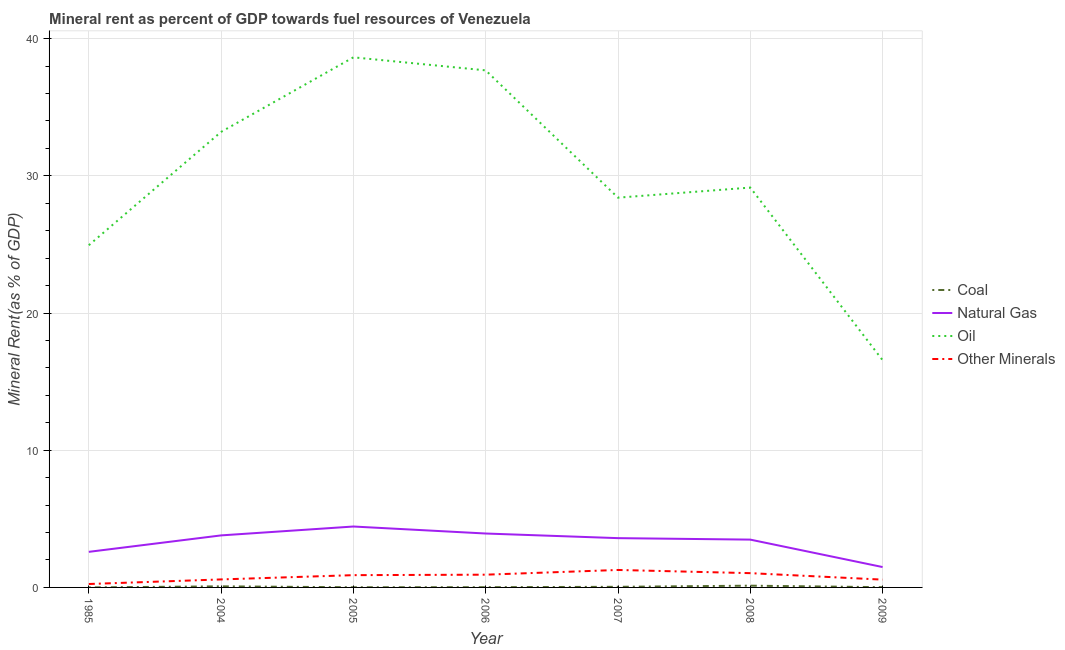Is the number of lines equal to the number of legend labels?
Offer a terse response. Yes. What is the coal rent in 2008?
Provide a short and direct response. 0.13. Across all years, what is the maximum  rent of other minerals?
Your answer should be compact. 1.27. Across all years, what is the minimum oil rent?
Make the answer very short. 16.57. In which year was the natural gas rent maximum?
Your answer should be compact. 2005. In which year was the  rent of other minerals minimum?
Give a very brief answer. 1985. What is the total oil rent in the graph?
Ensure brevity in your answer.  208.6. What is the difference between the oil rent in 2006 and that in 2009?
Provide a succinct answer. 21.13. What is the difference between the coal rent in 2009 and the oil rent in 2005?
Your answer should be very brief. -38.62. What is the average coal rent per year?
Ensure brevity in your answer.  0.04. In the year 2008, what is the difference between the natural gas rent and oil rent?
Ensure brevity in your answer.  -25.66. What is the ratio of the  rent of other minerals in 2006 to that in 2009?
Give a very brief answer. 1.64. Is the difference between the coal rent in 1985 and 2006 greater than the difference between the oil rent in 1985 and 2006?
Keep it short and to the point. Yes. What is the difference between the highest and the second highest oil rent?
Provide a succinct answer. 0.95. What is the difference between the highest and the lowest coal rent?
Your response must be concise. 0.13. In how many years, is the oil rent greater than the average oil rent taken over all years?
Your answer should be compact. 3. Is it the case that in every year, the sum of the natural gas rent and coal rent is greater than the sum of  rent of other minerals and oil rent?
Make the answer very short. No. Does the coal rent monotonically increase over the years?
Your answer should be compact. No. Is the coal rent strictly greater than the  rent of other minerals over the years?
Provide a short and direct response. No. How many lines are there?
Offer a terse response. 4. What is the difference between two consecutive major ticks on the Y-axis?
Your answer should be compact. 10. Are the values on the major ticks of Y-axis written in scientific E-notation?
Ensure brevity in your answer.  No. Does the graph contain grids?
Offer a very short reply. Yes. What is the title of the graph?
Give a very brief answer. Mineral rent as percent of GDP towards fuel resources of Venezuela. What is the label or title of the X-axis?
Offer a terse response. Year. What is the label or title of the Y-axis?
Provide a succinct answer. Mineral Rent(as % of GDP). What is the Mineral Rent(as % of GDP) of Coal in 1985?
Offer a very short reply. 0. What is the Mineral Rent(as % of GDP) in Natural Gas in 1985?
Keep it short and to the point. 2.59. What is the Mineral Rent(as % of GDP) in Oil in 1985?
Your answer should be compact. 24.94. What is the Mineral Rent(as % of GDP) in Other Minerals in 1985?
Your answer should be very brief. 0.25. What is the Mineral Rent(as % of GDP) in Coal in 2004?
Your answer should be compact. 0.08. What is the Mineral Rent(as % of GDP) in Natural Gas in 2004?
Provide a short and direct response. 3.79. What is the Mineral Rent(as % of GDP) in Oil in 2004?
Make the answer very short. 33.21. What is the Mineral Rent(as % of GDP) of Other Minerals in 2004?
Provide a short and direct response. 0.58. What is the Mineral Rent(as % of GDP) of Coal in 2005?
Offer a terse response. 0.01. What is the Mineral Rent(as % of GDP) of Natural Gas in 2005?
Offer a terse response. 4.44. What is the Mineral Rent(as % of GDP) of Oil in 2005?
Ensure brevity in your answer.  38.64. What is the Mineral Rent(as % of GDP) of Other Minerals in 2005?
Provide a succinct answer. 0.89. What is the Mineral Rent(as % of GDP) of Coal in 2006?
Keep it short and to the point. 0.02. What is the Mineral Rent(as % of GDP) of Natural Gas in 2006?
Your answer should be very brief. 3.93. What is the Mineral Rent(as % of GDP) in Oil in 2006?
Ensure brevity in your answer.  37.69. What is the Mineral Rent(as % of GDP) in Other Minerals in 2006?
Provide a succinct answer. 0.93. What is the Mineral Rent(as % of GDP) of Coal in 2007?
Offer a very short reply. 0.04. What is the Mineral Rent(as % of GDP) of Natural Gas in 2007?
Offer a very short reply. 3.59. What is the Mineral Rent(as % of GDP) of Oil in 2007?
Offer a terse response. 28.41. What is the Mineral Rent(as % of GDP) in Other Minerals in 2007?
Ensure brevity in your answer.  1.27. What is the Mineral Rent(as % of GDP) of Coal in 2008?
Provide a succinct answer. 0.13. What is the Mineral Rent(as % of GDP) of Natural Gas in 2008?
Provide a succinct answer. 3.49. What is the Mineral Rent(as % of GDP) in Oil in 2008?
Keep it short and to the point. 29.15. What is the Mineral Rent(as % of GDP) of Other Minerals in 2008?
Offer a very short reply. 1.04. What is the Mineral Rent(as % of GDP) of Coal in 2009?
Ensure brevity in your answer.  0.02. What is the Mineral Rent(as % of GDP) of Natural Gas in 2009?
Ensure brevity in your answer.  1.48. What is the Mineral Rent(as % of GDP) of Oil in 2009?
Your answer should be compact. 16.57. What is the Mineral Rent(as % of GDP) of Other Minerals in 2009?
Keep it short and to the point. 0.57. Across all years, what is the maximum Mineral Rent(as % of GDP) in Coal?
Give a very brief answer. 0.13. Across all years, what is the maximum Mineral Rent(as % of GDP) in Natural Gas?
Your answer should be very brief. 4.44. Across all years, what is the maximum Mineral Rent(as % of GDP) of Oil?
Give a very brief answer. 38.64. Across all years, what is the maximum Mineral Rent(as % of GDP) of Other Minerals?
Your answer should be very brief. 1.27. Across all years, what is the minimum Mineral Rent(as % of GDP) in Coal?
Give a very brief answer. 0. Across all years, what is the minimum Mineral Rent(as % of GDP) of Natural Gas?
Ensure brevity in your answer.  1.48. Across all years, what is the minimum Mineral Rent(as % of GDP) of Oil?
Keep it short and to the point. 16.57. Across all years, what is the minimum Mineral Rent(as % of GDP) in Other Minerals?
Provide a succinct answer. 0.25. What is the total Mineral Rent(as % of GDP) of Coal in the graph?
Provide a succinct answer. 0.3. What is the total Mineral Rent(as % of GDP) in Natural Gas in the graph?
Provide a succinct answer. 23.32. What is the total Mineral Rent(as % of GDP) of Oil in the graph?
Ensure brevity in your answer.  208.6. What is the total Mineral Rent(as % of GDP) of Other Minerals in the graph?
Ensure brevity in your answer.  5.54. What is the difference between the Mineral Rent(as % of GDP) of Coal in 1985 and that in 2004?
Make the answer very short. -0.08. What is the difference between the Mineral Rent(as % of GDP) of Natural Gas in 1985 and that in 2004?
Keep it short and to the point. -1.2. What is the difference between the Mineral Rent(as % of GDP) of Oil in 1985 and that in 2004?
Your answer should be very brief. -8.26. What is the difference between the Mineral Rent(as % of GDP) in Other Minerals in 1985 and that in 2004?
Give a very brief answer. -0.33. What is the difference between the Mineral Rent(as % of GDP) of Coal in 1985 and that in 2005?
Provide a succinct answer. -0.01. What is the difference between the Mineral Rent(as % of GDP) of Natural Gas in 1985 and that in 2005?
Make the answer very short. -1.85. What is the difference between the Mineral Rent(as % of GDP) in Oil in 1985 and that in 2005?
Provide a succinct answer. -13.7. What is the difference between the Mineral Rent(as % of GDP) in Other Minerals in 1985 and that in 2005?
Provide a succinct answer. -0.65. What is the difference between the Mineral Rent(as % of GDP) in Coal in 1985 and that in 2006?
Offer a terse response. -0.02. What is the difference between the Mineral Rent(as % of GDP) of Natural Gas in 1985 and that in 2006?
Make the answer very short. -1.34. What is the difference between the Mineral Rent(as % of GDP) of Oil in 1985 and that in 2006?
Offer a very short reply. -12.75. What is the difference between the Mineral Rent(as % of GDP) in Other Minerals in 1985 and that in 2006?
Give a very brief answer. -0.68. What is the difference between the Mineral Rent(as % of GDP) of Coal in 1985 and that in 2007?
Make the answer very short. -0.04. What is the difference between the Mineral Rent(as % of GDP) of Natural Gas in 1985 and that in 2007?
Keep it short and to the point. -1. What is the difference between the Mineral Rent(as % of GDP) in Oil in 1985 and that in 2007?
Your answer should be compact. -3.47. What is the difference between the Mineral Rent(as % of GDP) in Other Minerals in 1985 and that in 2007?
Offer a very short reply. -1.02. What is the difference between the Mineral Rent(as % of GDP) of Coal in 1985 and that in 2008?
Offer a terse response. -0.13. What is the difference between the Mineral Rent(as % of GDP) in Natural Gas in 1985 and that in 2008?
Offer a very short reply. -0.89. What is the difference between the Mineral Rent(as % of GDP) of Oil in 1985 and that in 2008?
Ensure brevity in your answer.  -4.2. What is the difference between the Mineral Rent(as % of GDP) of Other Minerals in 1985 and that in 2008?
Give a very brief answer. -0.79. What is the difference between the Mineral Rent(as % of GDP) of Coal in 1985 and that in 2009?
Your answer should be compact. -0.02. What is the difference between the Mineral Rent(as % of GDP) of Natural Gas in 1985 and that in 2009?
Provide a succinct answer. 1.11. What is the difference between the Mineral Rent(as % of GDP) in Oil in 1985 and that in 2009?
Your answer should be compact. 8.38. What is the difference between the Mineral Rent(as % of GDP) in Other Minerals in 1985 and that in 2009?
Offer a very short reply. -0.32. What is the difference between the Mineral Rent(as % of GDP) in Coal in 2004 and that in 2005?
Provide a succinct answer. 0.07. What is the difference between the Mineral Rent(as % of GDP) in Natural Gas in 2004 and that in 2005?
Your response must be concise. -0.65. What is the difference between the Mineral Rent(as % of GDP) of Oil in 2004 and that in 2005?
Your response must be concise. -5.43. What is the difference between the Mineral Rent(as % of GDP) of Other Minerals in 2004 and that in 2005?
Provide a succinct answer. -0.31. What is the difference between the Mineral Rent(as % of GDP) in Coal in 2004 and that in 2006?
Give a very brief answer. 0.06. What is the difference between the Mineral Rent(as % of GDP) of Natural Gas in 2004 and that in 2006?
Make the answer very short. -0.14. What is the difference between the Mineral Rent(as % of GDP) in Oil in 2004 and that in 2006?
Provide a succinct answer. -4.48. What is the difference between the Mineral Rent(as % of GDP) of Other Minerals in 2004 and that in 2006?
Keep it short and to the point. -0.35. What is the difference between the Mineral Rent(as % of GDP) of Coal in 2004 and that in 2007?
Give a very brief answer. 0.03. What is the difference between the Mineral Rent(as % of GDP) of Natural Gas in 2004 and that in 2007?
Offer a terse response. 0.2. What is the difference between the Mineral Rent(as % of GDP) in Oil in 2004 and that in 2007?
Your response must be concise. 4.79. What is the difference between the Mineral Rent(as % of GDP) in Other Minerals in 2004 and that in 2007?
Your answer should be compact. -0.69. What is the difference between the Mineral Rent(as % of GDP) in Coal in 2004 and that in 2008?
Provide a short and direct response. -0.05. What is the difference between the Mineral Rent(as % of GDP) in Natural Gas in 2004 and that in 2008?
Provide a succinct answer. 0.31. What is the difference between the Mineral Rent(as % of GDP) of Oil in 2004 and that in 2008?
Your answer should be very brief. 4.06. What is the difference between the Mineral Rent(as % of GDP) of Other Minerals in 2004 and that in 2008?
Keep it short and to the point. -0.46. What is the difference between the Mineral Rent(as % of GDP) in Coal in 2004 and that in 2009?
Keep it short and to the point. 0.06. What is the difference between the Mineral Rent(as % of GDP) in Natural Gas in 2004 and that in 2009?
Provide a short and direct response. 2.31. What is the difference between the Mineral Rent(as % of GDP) of Oil in 2004 and that in 2009?
Your response must be concise. 16.64. What is the difference between the Mineral Rent(as % of GDP) in Other Minerals in 2004 and that in 2009?
Your answer should be very brief. 0.02. What is the difference between the Mineral Rent(as % of GDP) of Coal in 2005 and that in 2006?
Give a very brief answer. -0.01. What is the difference between the Mineral Rent(as % of GDP) of Natural Gas in 2005 and that in 2006?
Offer a terse response. 0.51. What is the difference between the Mineral Rent(as % of GDP) in Oil in 2005 and that in 2006?
Keep it short and to the point. 0.95. What is the difference between the Mineral Rent(as % of GDP) of Other Minerals in 2005 and that in 2006?
Your response must be concise. -0.03. What is the difference between the Mineral Rent(as % of GDP) in Coal in 2005 and that in 2007?
Your answer should be very brief. -0.03. What is the difference between the Mineral Rent(as % of GDP) in Natural Gas in 2005 and that in 2007?
Your answer should be compact. 0.85. What is the difference between the Mineral Rent(as % of GDP) in Oil in 2005 and that in 2007?
Provide a short and direct response. 10.23. What is the difference between the Mineral Rent(as % of GDP) in Other Minerals in 2005 and that in 2007?
Give a very brief answer. -0.38. What is the difference between the Mineral Rent(as % of GDP) of Coal in 2005 and that in 2008?
Provide a succinct answer. -0.12. What is the difference between the Mineral Rent(as % of GDP) in Natural Gas in 2005 and that in 2008?
Provide a short and direct response. 0.95. What is the difference between the Mineral Rent(as % of GDP) of Oil in 2005 and that in 2008?
Provide a succinct answer. 9.49. What is the difference between the Mineral Rent(as % of GDP) in Other Minerals in 2005 and that in 2008?
Ensure brevity in your answer.  -0.15. What is the difference between the Mineral Rent(as % of GDP) in Coal in 2005 and that in 2009?
Offer a terse response. -0.01. What is the difference between the Mineral Rent(as % of GDP) in Natural Gas in 2005 and that in 2009?
Offer a terse response. 2.95. What is the difference between the Mineral Rent(as % of GDP) of Oil in 2005 and that in 2009?
Your answer should be very brief. 22.08. What is the difference between the Mineral Rent(as % of GDP) in Other Minerals in 2005 and that in 2009?
Provide a short and direct response. 0.33. What is the difference between the Mineral Rent(as % of GDP) in Coal in 2006 and that in 2007?
Provide a short and direct response. -0.03. What is the difference between the Mineral Rent(as % of GDP) of Natural Gas in 2006 and that in 2007?
Your response must be concise. 0.34. What is the difference between the Mineral Rent(as % of GDP) in Oil in 2006 and that in 2007?
Provide a succinct answer. 9.28. What is the difference between the Mineral Rent(as % of GDP) of Other Minerals in 2006 and that in 2007?
Keep it short and to the point. -0.34. What is the difference between the Mineral Rent(as % of GDP) of Coal in 2006 and that in 2008?
Provide a short and direct response. -0.11. What is the difference between the Mineral Rent(as % of GDP) of Natural Gas in 2006 and that in 2008?
Ensure brevity in your answer.  0.44. What is the difference between the Mineral Rent(as % of GDP) of Oil in 2006 and that in 2008?
Keep it short and to the point. 8.54. What is the difference between the Mineral Rent(as % of GDP) of Other Minerals in 2006 and that in 2008?
Make the answer very short. -0.11. What is the difference between the Mineral Rent(as % of GDP) of Coal in 2006 and that in 2009?
Make the answer very short. -0. What is the difference between the Mineral Rent(as % of GDP) in Natural Gas in 2006 and that in 2009?
Give a very brief answer. 2.45. What is the difference between the Mineral Rent(as % of GDP) of Oil in 2006 and that in 2009?
Your answer should be very brief. 21.13. What is the difference between the Mineral Rent(as % of GDP) in Other Minerals in 2006 and that in 2009?
Make the answer very short. 0.36. What is the difference between the Mineral Rent(as % of GDP) in Coal in 2007 and that in 2008?
Your answer should be very brief. -0.08. What is the difference between the Mineral Rent(as % of GDP) in Natural Gas in 2007 and that in 2008?
Your response must be concise. 0.11. What is the difference between the Mineral Rent(as % of GDP) of Oil in 2007 and that in 2008?
Offer a terse response. -0.74. What is the difference between the Mineral Rent(as % of GDP) in Other Minerals in 2007 and that in 2008?
Your answer should be compact. 0.23. What is the difference between the Mineral Rent(as % of GDP) in Coal in 2007 and that in 2009?
Make the answer very short. 0.03. What is the difference between the Mineral Rent(as % of GDP) of Natural Gas in 2007 and that in 2009?
Offer a very short reply. 2.11. What is the difference between the Mineral Rent(as % of GDP) in Oil in 2007 and that in 2009?
Provide a short and direct response. 11.85. What is the difference between the Mineral Rent(as % of GDP) in Other Minerals in 2007 and that in 2009?
Your answer should be compact. 0.7. What is the difference between the Mineral Rent(as % of GDP) of Coal in 2008 and that in 2009?
Your answer should be compact. 0.11. What is the difference between the Mineral Rent(as % of GDP) in Natural Gas in 2008 and that in 2009?
Provide a short and direct response. 2. What is the difference between the Mineral Rent(as % of GDP) in Oil in 2008 and that in 2009?
Offer a terse response. 12.58. What is the difference between the Mineral Rent(as % of GDP) of Other Minerals in 2008 and that in 2009?
Provide a short and direct response. 0.47. What is the difference between the Mineral Rent(as % of GDP) in Coal in 1985 and the Mineral Rent(as % of GDP) in Natural Gas in 2004?
Make the answer very short. -3.79. What is the difference between the Mineral Rent(as % of GDP) of Coal in 1985 and the Mineral Rent(as % of GDP) of Oil in 2004?
Provide a short and direct response. -33.21. What is the difference between the Mineral Rent(as % of GDP) of Coal in 1985 and the Mineral Rent(as % of GDP) of Other Minerals in 2004?
Provide a succinct answer. -0.58. What is the difference between the Mineral Rent(as % of GDP) of Natural Gas in 1985 and the Mineral Rent(as % of GDP) of Oil in 2004?
Offer a terse response. -30.61. What is the difference between the Mineral Rent(as % of GDP) of Natural Gas in 1985 and the Mineral Rent(as % of GDP) of Other Minerals in 2004?
Ensure brevity in your answer.  2.01. What is the difference between the Mineral Rent(as % of GDP) in Oil in 1985 and the Mineral Rent(as % of GDP) in Other Minerals in 2004?
Your answer should be compact. 24.36. What is the difference between the Mineral Rent(as % of GDP) of Coal in 1985 and the Mineral Rent(as % of GDP) of Natural Gas in 2005?
Provide a short and direct response. -4.44. What is the difference between the Mineral Rent(as % of GDP) of Coal in 1985 and the Mineral Rent(as % of GDP) of Oil in 2005?
Make the answer very short. -38.64. What is the difference between the Mineral Rent(as % of GDP) in Coal in 1985 and the Mineral Rent(as % of GDP) in Other Minerals in 2005?
Give a very brief answer. -0.89. What is the difference between the Mineral Rent(as % of GDP) in Natural Gas in 1985 and the Mineral Rent(as % of GDP) in Oil in 2005?
Offer a terse response. -36.05. What is the difference between the Mineral Rent(as % of GDP) of Natural Gas in 1985 and the Mineral Rent(as % of GDP) of Other Minerals in 2005?
Keep it short and to the point. 1.7. What is the difference between the Mineral Rent(as % of GDP) of Oil in 1985 and the Mineral Rent(as % of GDP) of Other Minerals in 2005?
Make the answer very short. 24.05. What is the difference between the Mineral Rent(as % of GDP) in Coal in 1985 and the Mineral Rent(as % of GDP) in Natural Gas in 2006?
Offer a terse response. -3.93. What is the difference between the Mineral Rent(as % of GDP) of Coal in 1985 and the Mineral Rent(as % of GDP) of Oil in 2006?
Provide a short and direct response. -37.69. What is the difference between the Mineral Rent(as % of GDP) in Coal in 1985 and the Mineral Rent(as % of GDP) in Other Minerals in 2006?
Your answer should be compact. -0.93. What is the difference between the Mineral Rent(as % of GDP) in Natural Gas in 1985 and the Mineral Rent(as % of GDP) in Oil in 2006?
Ensure brevity in your answer.  -35.1. What is the difference between the Mineral Rent(as % of GDP) of Natural Gas in 1985 and the Mineral Rent(as % of GDP) of Other Minerals in 2006?
Offer a very short reply. 1.66. What is the difference between the Mineral Rent(as % of GDP) in Oil in 1985 and the Mineral Rent(as % of GDP) in Other Minerals in 2006?
Your response must be concise. 24.01. What is the difference between the Mineral Rent(as % of GDP) in Coal in 1985 and the Mineral Rent(as % of GDP) in Natural Gas in 2007?
Provide a short and direct response. -3.59. What is the difference between the Mineral Rent(as % of GDP) in Coal in 1985 and the Mineral Rent(as % of GDP) in Oil in 2007?
Your response must be concise. -28.41. What is the difference between the Mineral Rent(as % of GDP) of Coal in 1985 and the Mineral Rent(as % of GDP) of Other Minerals in 2007?
Offer a terse response. -1.27. What is the difference between the Mineral Rent(as % of GDP) of Natural Gas in 1985 and the Mineral Rent(as % of GDP) of Oil in 2007?
Provide a short and direct response. -25.82. What is the difference between the Mineral Rent(as % of GDP) of Natural Gas in 1985 and the Mineral Rent(as % of GDP) of Other Minerals in 2007?
Keep it short and to the point. 1.32. What is the difference between the Mineral Rent(as % of GDP) in Oil in 1985 and the Mineral Rent(as % of GDP) in Other Minerals in 2007?
Provide a succinct answer. 23.67. What is the difference between the Mineral Rent(as % of GDP) in Coal in 1985 and the Mineral Rent(as % of GDP) in Natural Gas in 2008?
Give a very brief answer. -3.49. What is the difference between the Mineral Rent(as % of GDP) of Coal in 1985 and the Mineral Rent(as % of GDP) of Oil in 2008?
Your answer should be compact. -29.15. What is the difference between the Mineral Rent(as % of GDP) of Coal in 1985 and the Mineral Rent(as % of GDP) of Other Minerals in 2008?
Make the answer very short. -1.04. What is the difference between the Mineral Rent(as % of GDP) of Natural Gas in 1985 and the Mineral Rent(as % of GDP) of Oil in 2008?
Your answer should be compact. -26.55. What is the difference between the Mineral Rent(as % of GDP) of Natural Gas in 1985 and the Mineral Rent(as % of GDP) of Other Minerals in 2008?
Your response must be concise. 1.55. What is the difference between the Mineral Rent(as % of GDP) of Oil in 1985 and the Mineral Rent(as % of GDP) of Other Minerals in 2008?
Keep it short and to the point. 23.9. What is the difference between the Mineral Rent(as % of GDP) in Coal in 1985 and the Mineral Rent(as % of GDP) in Natural Gas in 2009?
Your response must be concise. -1.48. What is the difference between the Mineral Rent(as % of GDP) of Coal in 1985 and the Mineral Rent(as % of GDP) of Oil in 2009?
Provide a short and direct response. -16.57. What is the difference between the Mineral Rent(as % of GDP) of Coal in 1985 and the Mineral Rent(as % of GDP) of Other Minerals in 2009?
Provide a succinct answer. -0.57. What is the difference between the Mineral Rent(as % of GDP) of Natural Gas in 1985 and the Mineral Rent(as % of GDP) of Oil in 2009?
Your answer should be compact. -13.97. What is the difference between the Mineral Rent(as % of GDP) of Natural Gas in 1985 and the Mineral Rent(as % of GDP) of Other Minerals in 2009?
Keep it short and to the point. 2.03. What is the difference between the Mineral Rent(as % of GDP) in Oil in 1985 and the Mineral Rent(as % of GDP) in Other Minerals in 2009?
Keep it short and to the point. 24.38. What is the difference between the Mineral Rent(as % of GDP) in Coal in 2004 and the Mineral Rent(as % of GDP) in Natural Gas in 2005?
Offer a terse response. -4.36. What is the difference between the Mineral Rent(as % of GDP) of Coal in 2004 and the Mineral Rent(as % of GDP) of Oil in 2005?
Provide a succinct answer. -38.56. What is the difference between the Mineral Rent(as % of GDP) in Coal in 2004 and the Mineral Rent(as % of GDP) in Other Minerals in 2005?
Offer a terse response. -0.82. What is the difference between the Mineral Rent(as % of GDP) of Natural Gas in 2004 and the Mineral Rent(as % of GDP) of Oil in 2005?
Your answer should be very brief. -34.85. What is the difference between the Mineral Rent(as % of GDP) in Natural Gas in 2004 and the Mineral Rent(as % of GDP) in Other Minerals in 2005?
Keep it short and to the point. 2.9. What is the difference between the Mineral Rent(as % of GDP) of Oil in 2004 and the Mineral Rent(as % of GDP) of Other Minerals in 2005?
Offer a terse response. 32.31. What is the difference between the Mineral Rent(as % of GDP) in Coal in 2004 and the Mineral Rent(as % of GDP) in Natural Gas in 2006?
Offer a very short reply. -3.85. What is the difference between the Mineral Rent(as % of GDP) of Coal in 2004 and the Mineral Rent(as % of GDP) of Oil in 2006?
Your answer should be compact. -37.61. What is the difference between the Mineral Rent(as % of GDP) of Coal in 2004 and the Mineral Rent(as % of GDP) of Other Minerals in 2006?
Provide a succinct answer. -0.85. What is the difference between the Mineral Rent(as % of GDP) of Natural Gas in 2004 and the Mineral Rent(as % of GDP) of Oil in 2006?
Your response must be concise. -33.9. What is the difference between the Mineral Rent(as % of GDP) in Natural Gas in 2004 and the Mineral Rent(as % of GDP) in Other Minerals in 2006?
Make the answer very short. 2.86. What is the difference between the Mineral Rent(as % of GDP) of Oil in 2004 and the Mineral Rent(as % of GDP) of Other Minerals in 2006?
Ensure brevity in your answer.  32.28. What is the difference between the Mineral Rent(as % of GDP) of Coal in 2004 and the Mineral Rent(as % of GDP) of Natural Gas in 2007?
Offer a terse response. -3.51. What is the difference between the Mineral Rent(as % of GDP) in Coal in 2004 and the Mineral Rent(as % of GDP) in Oil in 2007?
Your answer should be compact. -28.33. What is the difference between the Mineral Rent(as % of GDP) in Coal in 2004 and the Mineral Rent(as % of GDP) in Other Minerals in 2007?
Make the answer very short. -1.19. What is the difference between the Mineral Rent(as % of GDP) of Natural Gas in 2004 and the Mineral Rent(as % of GDP) of Oil in 2007?
Your response must be concise. -24.62. What is the difference between the Mineral Rent(as % of GDP) in Natural Gas in 2004 and the Mineral Rent(as % of GDP) in Other Minerals in 2007?
Offer a terse response. 2.52. What is the difference between the Mineral Rent(as % of GDP) in Oil in 2004 and the Mineral Rent(as % of GDP) in Other Minerals in 2007?
Provide a short and direct response. 31.93. What is the difference between the Mineral Rent(as % of GDP) of Coal in 2004 and the Mineral Rent(as % of GDP) of Natural Gas in 2008?
Your response must be concise. -3.41. What is the difference between the Mineral Rent(as % of GDP) of Coal in 2004 and the Mineral Rent(as % of GDP) of Oil in 2008?
Your answer should be very brief. -29.07. What is the difference between the Mineral Rent(as % of GDP) of Coal in 2004 and the Mineral Rent(as % of GDP) of Other Minerals in 2008?
Make the answer very short. -0.96. What is the difference between the Mineral Rent(as % of GDP) of Natural Gas in 2004 and the Mineral Rent(as % of GDP) of Oil in 2008?
Keep it short and to the point. -25.35. What is the difference between the Mineral Rent(as % of GDP) of Natural Gas in 2004 and the Mineral Rent(as % of GDP) of Other Minerals in 2008?
Your answer should be compact. 2.75. What is the difference between the Mineral Rent(as % of GDP) in Oil in 2004 and the Mineral Rent(as % of GDP) in Other Minerals in 2008?
Offer a very short reply. 32.17. What is the difference between the Mineral Rent(as % of GDP) in Coal in 2004 and the Mineral Rent(as % of GDP) in Natural Gas in 2009?
Offer a very short reply. -1.41. What is the difference between the Mineral Rent(as % of GDP) in Coal in 2004 and the Mineral Rent(as % of GDP) in Oil in 2009?
Provide a succinct answer. -16.49. What is the difference between the Mineral Rent(as % of GDP) of Coal in 2004 and the Mineral Rent(as % of GDP) of Other Minerals in 2009?
Keep it short and to the point. -0.49. What is the difference between the Mineral Rent(as % of GDP) in Natural Gas in 2004 and the Mineral Rent(as % of GDP) in Oil in 2009?
Your answer should be compact. -12.77. What is the difference between the Mineral Rent(as % of GDP) of Natural Gas in 2004 and the Mineral Rent(as % of GDP) of Other Minerals in 2009?
Provide a succinct answer. 3.22. What is the difference between the Mineral Rent(as % of GDP) of Oil in 2004 and the Mineral Rent(as % of GDP) of Other Minerals in 2009?
Make the answer very short. 32.64. What is the difference between the Mineral Rent(as % of GDP) of Coal in 2005 and the Mineral Rent(as % of GDP) of Natural Gas in 2006?
Keep it short and to the point. -3.92. What is the difference between the Mineral Rent(as % of GDP) in Coal in 2005 and the Mineral Rent(as % of GDP) in Oil in 2006?
Keep it short and to the point. -37.68. What is the difference between the Mineral Rent(as % of GDP) in Coal in 2005 and the Mineral Rent(as % of GDP) in Other Minerals in 2006?
Your answer should be very brief. -0.92. What is the difference between the Mineral Rent(as % of GDP) of Natural Gas in 2005 and the Mineral Rent(as % of GDP) of Oil in 2006?
Keep it short and to the point. -33.25. What is the difference between the Mineral Rent(as % of GDP) in Natural Gas in 2005 and the Mineral Rent(as % of GDP) in Other Minerals in 2006?
Ensure brevity in your answer.  3.51. What is the difference between the Mineral Rent(as % of GDP) in Oil in 2005 and the Mineral Rent(as % of GDP) in Other Minerals in 2006?
Ensure brevity in your answer.  37.71. What is the difference between the Mineral Rent(as % of GDP) in Coal in 2005 and the Mineral Rent(as % of GDP) in Natural Gas in 2007?
Keep it short and to the point. -3.58. What is the difference between the Mineral Rent(as % of GDP) of Coal in 2005 and the Mineral Rent(as % of GDP) of Oil in 2007?
Make the answer very short. -28.4. What is the difference between the Mineral Rent(as % of GDP) of Coal in 2005 and the Mineral Rent(as % of GDP) of Other Minerals in 2007?
Provide a short and direct response. -1.26. What is the difference between the Mineral Rent(as % of GDP) in Natural Gas in 2005 and the Mineral Rent(as % of GDP) in Oil in 2007?
Ensure brevity in your answer.  -23.97. What is the difference between the Mineral Rent(as % of GDP) in Natural Gas in 2005 and the Mineral Rent(as % of GDP) in Other Minerals in 2007?
Ensure brevity in your answer.  3.17. What is the difference between the Mineral Rent(as % of GDP) of Oil in 2005 and the Mineral Rent(as % of GDP) of Other Minerals in 2007?
Provide a short and direct response. 37.37. What is the difference between the Mineral Rent(as % of GDP) in Coal in 2005 and the Mineral Rent(as % of GDP) in Natural Gas in 2008?
Keep it short and to the point. -3.47. What is the difference between the Mineral Rent(as % of GDP) of Coal in 2005 and the Mineral Rent(as % of GDP) of Oil in 2008?
Your response must be concise. -29.13. What is the difference between the Mineral Rent(as % of GDP) of Coal in 2005 and the Mineral Rent(as % of GDP) of Other Minerals in 2008?
Your answer should be very brief. -1.03. What is the difference between the Mineral Rent(as % of GDP) of Natural Gas in 2005 and the Mineral Rent(as % of GDP) of Oil in 2008?
Offer a very short reply. -24.71. What is the difference between the Mineral Rent(as % of GDP) in Natural Gas in 2005 and the Mineral Rent(as % of GDP) in Other Minerals in 2008?
Your answer should be very brief. 3.4. What is the difference between the Mineral Rent(as % of GDP) of Oil in 2005 and the Mineral Rent(as % of GDP) of Other Minerals in 2008?
Provide a succinct answer. 37.6. What is the difference between the Mineral Rent(as % of GDP) of Coal in 2005 and the Mineral Rent(as % of GDP) of Natural Gas in 2009?
Give a very brief answer. -1.47. What is the difference between the Mineral Rent(as % of GDP) of Coal in 2005 and the Mineral Rent(as % of GDP) of Oil in 2009?
Make the answer very short. -16.55. What is the difference between the Mineral Rent(as % of GDP) of Coal in 2005 and the Mineral Rent(as % of GDP) of Other Minerals in 2009?
Make the answer very short. -0.56. What is the difference between the Mineral Rent(as % of GDP) of Natural Gas in 2005 and the Mineral Rent(as % of GDP) of Oil in 2009?
Your answer should be compact. -12.13. What is the difference between the Mineral Rent(as % of GDP) of Natural Gas in 2005 and the Mineral Rent(as % of GDP) of Other Minerals in 2009?
Your answer should be very brief. 3.87. What is the difference between the Mineral Rent(as % of GDP) in Oil in 2005 and the Mineral Rent(as % of GDP) in Other Minerals in 2009?
Keep it short and to the point. 38.07. What is the difference between the Mineral Rent(as % of GDP) in Coal in 2006 and the Mineral Rent(as % of GDP) in Natural Gas in 2007?
Offer a very short reply. -3.58. What is the difference between the Mineral Rent(as % of GDP) in Coal in 2006 and the Mineral Rent(as % of GDP) in Oil in 2007?
Your response must be concise. -28.39. What is the difference between the Mineral Rent(as % of GDP) in Coal in 2006 and the Mineral Rent(as % of GDP) in Other Minerals in 2007?
Give a very brief answer. -1.26. What is the difference between the Mineral Rent(as % of GDP) of Natural Gas in 2006 and the Mineral Rent(as % of GDP) of Oil in 2007?
Provide a short and direct response. -24.48. What is the difference between the Mineral Rent(as % of GDP) in Natural Gas in 2006 and the Mineral Rent(as % of GDP) in Other Minerals in 2007?
Give a very brief answer. 2.66. What is the difference between the Mineral Rent(as % of GDP) of Oil in 2006 and the Mineral Rent(as % of GDP) of Other Minerals in 2007?
Ensure brevity in your answer.  36.42. What is the difference between the Mineral Rent(as % of GDP) in Coal in 2006 and the Mineral Rent(as % of GDP) in Natural Gas in 2008?
Offer a very short reply. -3.47. What is the difference between the Mineral Rent(as % of GDP) of Coal in 2006 and the Mineral Rent(as % of GDP) of Oil in 2008?
Give a very brief answer. -29.13. What is the difference between the Mineral Rent(as % of GDP) of Coal in 2006 and the Mineral Rent(as % of GDP) of Other Minerals in 2008?
Make the answer very short. -1.02. What is the difference between the Mineral Rent(as % of GDP) of Natural Gas in 2006 and the Mineral Rent(as % of GDP) of Oil in 2008?
Provide a succinct answer. -25.22. What is the difference between the Mineral Rent(as % of GDP) in Natural Gas in 2006 and the Mineral Rent(as % of GDP) in Other Minerals in 2008?
Ensure brevity in your answer.  2.89. What is the difference between the Mineral Rent(as % of GDP) in Oil in 2006 and the Mineral Rent(as % of GDP) in Other Minerals in 2008?
Ensure brevity in your answer.  36.65. What is the difference between the Mineral Rent(as % of GDP) in Coal in 2006 and the Mineral Rent(as % of GDP) in Natural Gas in 2009?
Your answer should be compact. -1.47. What is the difference between the Mineral Rent(as % of GDP) of Coal in 2006 and the Mineral Rent(as % of GDP) of Oil in 2009?
Offer a very short reply. -16.55. What is the difference between the Mineral Rent(as % of GDP) in Coal in 2006 and the Mineral Rent(as % of GDP) in Other Minerals in 2009?
Provide a succinct answer. -0.55. What is the difference between the Mineral Rent(as % of GDP) of Natural Gas in 2006 and the Mineral Rent(as % of GDP) of Oil in 2009?
Ensure brevity in your answer.  -12.64. What is the difference between the Mineral Rent(as % of GDP) in Natural Gas in 2006 and the Mineral Rent(as % of GDP) in Other Minerals in 2009?
Your answer should be compact. 3.36. What is the difference between the Mineral Rent(as % of GDP) in Oil in 2006 and the Mineral Rent(as % of GDP) in Other Minerals in 2009?
Your answer should be very brief. 37.12. What is the difference between the Mineral Rent(as % of GDP) in Coal in 2007 and the Mineral Rent(as % of GDP) in Natural Gas in 2008?
Your response must be concise. -3.44. What is the difference between the Mineral Rent(as % of GDP) in Coal in 2007 and the Mineral Rent(as % of GDP) in Oil in 2008?
Your response must be concise. -29.1. What is the difference between the Mineral Rent(as % of GDP) of Coal in 2007 and the Mineral Rent(as % of GDP) of Other Minerals in 2008?
Offer a very short reply. -1. What is the difference between the Mineral Rent(as % of GDP) of Natural Gas in 2007 and the Mineral Rent(as % of GDP) of Oil in 2008?
Your answer should be very brief. -25.55. What is the difference between the Mineral Rent(as % of GDP) of Natural Gas in 2007 and the Mineral Rent(as % of GDP) of Other Minerals in 2008?
Ensure brevity in your answer.  2.55. What is the difference between the Mineral Rent(as % of GDP) of Oil in 2007 and the Mineral Rent(as % of GDP) of Other Minerals in 2008?
Keep it short and to the point. 27.37. What is the difference between the Mineral Rent(as % of GDP) of Coal in 2007 and the Mineral Rent(as % of GDP) of Natural Gas in 2009?
Give a very brief answer. -1.44. What is the difference between the Mineral Rent(as % of GDP) of Coal in 2007 and the Mineral Rent(as % of GDP) of Oil in 2009?
Ensure brevity in your answer.  -16.52. What is the difference between the Mineral Rent(as % of GDP) in Coal in 2007 and the Mineral Rent(as % of GDP) in Other Minerals in 2009?
Give a very brief answer. -0.52. What is the difference between the Mineral Rent(as % of GDP) of Natural Gas in 2007 and the Mineral Rent(as % of GDP) of Oil in 2009?
Keep it short and to the point. -12.97. What is the difference between the Mineral Rent(as % of GDP) in Natural Gas in 2007 and the Mineral Rent(as % of GDP) in Other Minerals in 2009?
Make the answer very short. 3.02. What is the difference between the Mineral Rent(as % of GDP) in Oil in 2007 and the Mineral Rent(as % of GDP) in Other Minerals in 2009?
Provide a succinct answer. 27.84. What is the difference between the Mineral Rent(as % of GDP) of Coal in 2008 and the Mineral Rent(as % of GDP) of Natural Gas in 2009?
Give a very brief answer. -1.36. What is the difference between the Mineral Rent(as % of GDP) in Coal in 2008 and the Mineral Rent(as % of GDP) in Oil in 2009?
Your answer should be very brief. -16.44. What is the difference between the Mineral Rent(as % of GDP) in Coal in 2008 and the Mineral Rent(as % of GDP) in Other Minerals in 2009?
Offer a very short reply. -0.44. What is the difference between the Mineral Rent(as % of GDP) of Natural Gas in 2008 and the Mineral Rent(as % of GDP) of Oil in 2009?
Provide a short and direct response. -13.08. What is the difference between the Mineral Rent(as % of GDP) in Natural Gas in 2008 and the Mineral Rent(as % of GDP) in Other Minerals in 2009?
Your answer should be compact. 2.92. What is the difference between the Mineral Rent(as % of GDP) in Oil in 2008 and the Mineral Rent(as % of GDP) in Other Minerals in 2009?
Offer a very short reply. 28.58. What is the average Mineral Rent(as % of GDP) in Coal per year?
Offer a terse response. 0.04. What is the average Mineral Rent(as % of GDP) of Natural Gas per year?
Your answer should be compact. 3.33. What is the average Mineral Rent(as % of GDP) of Oil per year?
Offer a very short reply. 29.8. What is the average Mineral Rent(as % of GDP) of Other Minerals per year?
Make the answer very short. 0.79. In the year 1985, what is the difference between the Mineral Rent(as % of GDP) in Coal and Mineral Rent(as % of GDP) in Natural Gas?
Your answer should be compact. -2.59. In the year 1985, what is the difference between the Mineral Rent(as % of GDP) in Coal and Mineral Rent(as % of GDP) in Oil?
Keep it short and to the point. -24.94. In the year 1985, what is the difference between the Mineral Rent(as % of GDP) in Coal and Mineral Rent(as % of GDP) in Other Minerals?
Your answer should be compact. -0.25. In the year 1985, what is the difference between the Mineral Rent(as % of GDP) in Natural Gas and Mineral Rent(as % of GDP) in Oil?
Provide a succinct answer. -22.35. In the year 1985, what is the difference between the Mineral Rent(as % of GDP) of Natural Gas and Mineral Rent(as % of GDP) of Other Minerals?
Your answer should be very brief. 2.34. In the year 1985, what is the difference between the Mineral Rent(as % of GDP) in Oil and Mineral Rent(as % of GDP) in Other Minerals?
Offer a very short reply. 24.7. In the year 2004, what is the difference between the Mineral Rent(as % of GDP) of Coal and Mineral Rent(as % of GDP) of Natural Gas?
Your answer should be very brief. -3.71. In the year 2004, what is the difference between the Mineral Rent(as % of GDP) of Coal and Mineral Rent(as % of GDP) of Oil?
Your answer should be very brief. -33.13. In the year 2004, what is the difference between the Mineral Rent(as % of GDP) in Coal and Mineral Rent(as % of GDP) in Other Minerals?
Provide a succinct answer. -0.5. In the year 2004, what is the difference between the Mineral Rent(as % of GDP) of Natural Gas and Mineral Rent(as % of GDP) of Oil?
Keep it short and to the point. -29.41. In the year 2004, what is the difference between the Mineral Rent(as % of GDP) in Natural Gas and Mineral Rent(as % of GDP) in Other Minerals?
Provide a succinct answer. 3.21. In the year 2004, what is the difference between the Mineral Rent(as % of GDP) in Oil and Mineral Rent(as % of GDP) in Other Minerals?
Make the answer very short. 32.62. In the year 2005, what is the difference between the Mineral Rent(as % of GDP) of Coal and Mineral Rent(as % of GDP) of Natural Gas?
Provide a succinct answer. -4.43. In the year 2005, what is the difference between the Mineral Rent(as % of GDP) of Coal and Mineral Rent(as % of GDP) of Oil?
Your answer should be compact. -38.63. In the year 2005, what is the difference between the Mineral Rent(as % of GDP) of Coal and Mineral Rent(as % of GDP) of Other Minerals?
Offer a terse response. -0.88. In the year 2005, what is the difference between the Mineral Rent(as % of GDP) of Natural Gas and Mineral Rent(as % of GDP) of Oil?
Your answer should be compact. -34.2. In the year 2005, what is the difference between the Mineral Rent(as % of GDP) of Natural Gas and Mineral Rent(as % of GDP) of Other Minerals?
Give a very brief answer. 3.54. In the year 2005, what is the difference between the Mineral Rent(as % of GDP) of Oil and Mineral Rent(as % of GDP) of Other Minerals?
Your answer should be very brief. 37.75. In the year 2006, what is the difference between the Mineral Rent(as % of GDP) of Coal and Mineral Rent(as % of GDP) of Natural Gas?
Provide a short and direct response. -3.91. In the year 2006, what is the difference between the Mineral Rent(as % of GDP) of Coal and Mineral Rent(as % of GDP) of Oil?
Provide a succinct answer. -37.67. In the year 2006, what is the difference between the Mineral Rent(as % of GDP) in Coal and Mineral Rent(as % of GDP) in Other Minerals?
Ensure brevity in your answer.  -0.91. In the year 2006, what is the difference between the Mineral Rent(as % of GDP) of Natural Gas and Mineral Rent(as % of GDP) of Oil?
Make the answer very short. -33.76. In the year 2006, what is the difference between the Mineral Rent(as % of GDP) in Natural Gas and Mineral Rent(as % of GDP) in Other Minerals?
Your answer should be compact. 3. In the year 2006, what is the difference between the Mineral Rent(as % of GDP) of Oil and Mineral Rent(as % of GDP) of Other Minerals?
Provide a short and direct response. 36.76. In the year 2007, what is the difference between the Mineral Rent(as % of GDP) in Coal and Mineral Rent(as % of GDP) in Natural Gas?
Your response must be concise. -3.55. In the year 2007, what is the difference between the Mineral Rent(as % of GDP) in Coal and Mineral Rent(as % of GDP) in Oil?
Make the answer very short. -28.37. In the year 2007, what is the difference between the Mineral Rent(as % of GDP) of Coal and Mineral Rent(as % of GDP) of Other Minerals?
Your answer should be compact. -1.23. In the year 2007, what is the difference between the Mineral Rent(as % of GDP) of Natural Gas and Mineral Rent(as % of GDP) of Oil?
Your response must be concise. -24.82. In the year 2007, what is the difference between the Mineral Rent(as % of GDP) in Natural Gas and Mineral Rent(as % of GDP) in Other Minerals?
Keep it short and to the point. 2.32. In the year 2007, what is the difference between the Mineral Rent(as % of GDP) in Oil and Mineral Rent(as % of GDP) in Other Minerals?
Make the answer very short. 27.14. In the year 2008, what is the difference between the Mineral Rent(as % of GDP) in Coal and Mineral Rent(as % of GDP) in Natural Gas?
Offer a terse response. -3.36. In the year 2008, what is the difference between the Mineral Rent(as % of GDP) in Coal and Mineral Rent(as % of GDP) in Oil?
Provide a short and direct response. -29.02. In the year 2008, what is the difference between the Mineral Rent(as % of GDP) in Coal and Mineral Rent(as % of GDP) in Other Minerals?
Your answer should be very brief. -0.91. In the year 2008, what is the difference between the Mineral Rent(as % of GDP) in Natural Gas and Mineral Rent(as % of GDP) in Oil?
Your answer should be very brief. -25.66. In the year 2008, what is the difference between the Mineral Rent(as % of GDP) of Natural Gas and Mineral Rent(as % of GDP) of Other Minerals?
Your response must be concise. 2.44. In the year 2008, what is the difference between the Mineral Rent(as % of GDP) of Oil and Mineral Rent(as % of GDP) of Other Minerals?
Offer a terse response. 28.11. In the year 2009, what is the difference between the Mineral Rent(as % of GDP) of Coal and Mineral Rent(as % of GDP) of Natural Gas?
Ensure brevity in your answer.  -1.47. In the year 2009, what is the difference between the Mineral Rent(as % of GDP) of Coal and Mineral Rent(as % of GDP) of Oil?
Offer a terse response. -16.55. In the year 2009, what is the difference between the Mineral Rent(as % of GDP) in Coal and Mineral Rent(as % of GDP) in Other Minerals?
Provide a succinct answer. -0.55. In the year 2009, what is the difference between the Mineral Rent(as % of GDP) of Natural Gas and Mineral Rent(as % of GDP) of Oil?
Offer a very short reply. -15.08. In the year 2009, what is the difference between the Mineral Rent(as % of GDP) of Natural Gas and Mineral Rent(as % of GDP) of Other Minerals?
Provide a short and direct response. 0.92. In the year 2009, what is the difference between the Mineral Rent(as % of GDP) in Oil and Mineral Rent(as % of GDP) in Other Minerals?
Offer a terse response. 16. What is the ratio of the Mineral Rent(as % of GDP) of Coal in 1985 to that in 2004?
Make the answer very short. 0. What is the ratio of the Mineral Rent(as % of GDP) in Natural Gas in 1985 to that in 2004?
Offer a very short reply. 0.68. What is the ratio of the Mineral Rent(as % of GDP) of Oil in 1985 to that in 2004?
Offer a terse response. 0.75. What is the ratio of the Mineral Rent(as % of GDP) of Other Minerals in 1985 to that in 2004?
Offer a terse response. 0.43. What is the ratio of the Mineral Rent(as % of GDP) in Coal in 1985 to that in 2005?
Provide a succinct answer. 0.01. What is the ratio of the Mineral Rent(as % of GDP) of Natural Gas in 1985 to that in 2005?
Offer a terse response. 0.58. What is the ratio of the Mineral Rent(as % of GDP) in Oil in 1985 to that in 2005?
Offer a very short reply. 0.65. What is the ratio of the Mineral Rent(as % of GDP) in Other Minerals in 1985 to that in 2005?
Provide a short and direct response. 0.28. What is the ratio of the Mineral Rent(as % of GDP) in Coal in 1985 to that in 2006?
Provide a short and direct response. 0.01. What is the ratio of the Mineral Rent(as % of GDP) of Natural Gas in 1985 to that in 2006?
Make the answer very short. 0.66. What is the ratio of the Mineral Rent(as % of GDP) of Oil in 1985 to that in 2006?
Make the answer very short. 0.66. What is the ratio of the Mineral Rent(as % of GDP) of Other Minerals in 1985 to that in 2006?
Offer a very short reply. 0.27. What is the ratio of the Mineral Rent(as % of GDP) in Coal in 1985 to that in 2007?
Your answer should be very brief. 0. What is the ratio of the Mineral Rent(as % of GDP) of Natural Gas in 1985 to that in 2007?
Give a very brief answer. 0.72. What is the ratio of the Mineral Rent(as % of GDP) in Oil in 1985 to that in 2007?
Make the answer very short. 0.88. What is the ratio of the Mineral Rent(as % of GDP) of Other Minerals in 1985 to that in 2007?
Offer a terse response. 0.2. What is the ratio of the Mineral Rent(as % of GDP) in Coal in 1985 to that in 2008?
Your response must be concise. 0. What is the ratio of the Mineral Rent(as % of GDP) in Natural Gas in 1985 to that in 2008?
Make the answer very short. 0.74. What is the ratio of the Mineral Rent(as % of GDP) in Oil in 1985 to that in 2008?
Your answer should be compact. 0.86. What is the ratio of the Mineral Rent(as % of GDP) in Other Minerals in 1985 to that in 2008?
Provide a succinct answer. 0.24. What is the ratio of the Mineral Rent(as % of GDP) in Coal in 1985 to that in 2009?
Provide a short and direct response. 0.01. What is the ratio of the Mineral Rent(as % of GDP) of Natural Gas in 1985 to that in 2009?
Provide a succinct answer. 1.75. What is the ratio of the Mineral Rent(as % of GDP) of Oil in 1985 to that in 2009?
Offer a very short reply. 1.51. What is the ratio of the Mineral Rent(as % of GDP) of Other Minerals in 1985 to that in 2009?
Provide a succinct answer. 0.44. What is the ratio of the Mineral Rent(as % of GDP) in Coal in 2004 to that in 2005?
Give a very brief answer. 6.54. What is the ratio of the Mineral Rent(as % of GDP) in Natural Gas in 2004 to that in 2005?
Your answer should be compact. 0.85. What is the ratio of the Mineral Rent(as % of GDP) of Oil in 2004 to that in 2005?
Ensure brevity in your answer.  0.86. What is the ratio of the Mineral Rent(as % of GDP) in Other Minerals in 2004 to that in 2005?
Make the answer very short. 0.65. What is the ratio of the Mineral Rent(as % of GDP) in Coal in 2004 to that in 2006?
Give a very brief answer. 4.63. What is the ratio of the Mineral Rent(as % of GDP) of Natural Gas in 2004 to that in 2006?
Your response must be concise. 0.97. What is the ratio of the Mineral Rent(as % of GDP) of Oil in 2004 to that in 2006?
Make the answer very short. 0.88. What is the ratio of the Mineral Rent(as % of GDP) in Other Minerals in 2004 to that in 2006?
Give a very brief answer. 0.63. What is the ratio of the Mineral Rent(as % of GDP) of Coal in 2004 to that in 2007?
Your answer should be very brief. 1.78. What is the ratio of the Mineral Rent(as % of GDP) in Natural Gas in 2004 to that in 2007?
Ensure brevity in your answer.  1.06. What is the ratio of the Mineral Rent(as % of GDP) in Oil in 2004 to that in 2007?
Give a very brief answer. 1.17. What is the ratio of the Mineral Rent(as % of GDP) in Other Minerals in 2004 to that in 2007?
Offer a terse response. 0.46. What is the ratio of the Mineral Rent(as % of GDP) of Coal in 2004 to that in 2008?
Give a very brief answer. 0.62. What is the ratio of the Mineral Rent(as % of GDP) of Natural Gas in 2004 to that in 2008?
Offer a terse response. 1.09. What is the ratio of the Mineral Rent(as % of GDP) of Oil in 2004 to that in 2008?
Make the answer very short. 1.14. What is the ratio of the Mineral Rent(as % of GDP) of Other Minerals in 2004 to that in 2008?
Give a very brief answer. 0.56. What is the ratio of the Mineral Rent(as % of GDP) in Coal in 2004 to that in 2009?
Ensure brevity in your answer.  4.49. What is the ratio of the Mineral Rent(as % of GDP) in Natural Gas in 2004 to that in 2009?
Your answer should be compact. 2.55. What is the ratio of the Mineral Rent(as % of GDP) in Oil in 2004 to that in 2009?
Your answer should be compact. 2. What is the ratio of the Mineral Rent(as % of GDP) of Other Minerals in 2004 to that in 2009?
Your answer should be compact. 1.03. What is the ratio of the Mineral Rent(as % of GDP) in Coal in 2005 to that in 2006?
Make the answer very short. 0.71. What is the ratio of the Mineral Rent(as % of GDP) of Natural Gas in 2005 to that in 2006?
Make the answer very short. 1.13. What is the ratio of the Mineral Rent(as % of GDP) in Oil in 2005 to that in 2006?
Offer a very short reply. 1.03. What is the ratio of the Mineral Rent(as % of GDP) of Other Minerals in 2005 to that in 2006?
Offer a very short reply. 0.96. What is the ratio of the Mineral Rent(as % of GDP) of Coal in 2005 to that in 2007?
Your answer should be compact. 0.27. What is the ratio of the Mineral Rent(as % of GDP) in Natural Gas in 2005 to that in 2007?
Offer a very short reply. 1.24. What is the ratio of the Mineral Rent(as % of GDP) of Oil in 2005 to that in 2007?
Ensure brevity in your answer.  1.36. What is the ratio of the Mineral Rent(as % of GDP) in Other Minerals in 2005 to that in 2007?
Offer a very short reply. 0.7. What is the ratio of the Mineral Rent(as % of GDP) of Coal in 2005 to that in 2008?
Provide a short and direct response. 0.1. What is the ratio of the Mineral Rent(as % of GDP) in Natural Gas in 2005 to that in 2008?
Your answer should be very brief. 1.27. What is the ratio of the Mineral Rent(as % of GDP) of Oil in 2005 to that in 2008?
Keep it short and to the point. 1.33. What is the ratio of the Mineral Rent(as % of GDP) of Other Minerals in 2005 to that in 2008?
Make the answer very short. 0.86. What is the ratio of the Mineral Rent(as % of GDP) of Coal in 2005 to that in 2009?
Offer a very short reply. 0.69. What is the ratio of the Mineral Rent(as % of GDP) of Natural Gas in 2005 to that in 2009?
Make the answer very short. 2.99. What is the ratio of the Mineral Rent(as % of GDP) in Oil in 2005 to that in 2009?
Ensure brevity in your answer.  2.33. What is the ratio of the Mineral Rent(as % of GDP) of Other Minerals in 2005 to that in 2009?
Make the answer very short. 1.58. What is the ratio of the Mineral Rent(as % of GDP) of Coal in 2006 to that in 2007?
Provide a short and direct response. 0.38. What is the ratio of the Mineral Rent(as % of GDP) of Natural Gas in 2006 to that in 2007?
Your answer should be very brief. 1.09. What is the ratio of the Mineral Rent(as % of GDP) in Oil in 2006 to that in 2007?
Your answer should be compact. 1.33. What is the ratio of the Mineral Rent(as % of GDP) of Other Minerals in 2006 to that in 2007?
Make the answer very short. 0.73. What is the ratio of the Mineral Rent(as % of GDP) in Coal in 2006 to that in 2008?
Provide a succinct answer. 0.13. What is the ratio of the Mineral Rent(as % of GDP) of Natural Gas in 2006 to that in 2008?
Keep it short and to the point. 1.13. What is the ratio of the Mineral Rent(as % of GDP) in Oil in 2006 to that in 2008?
Your answer should be compact. 1.29. What is the ratio of the Mineral Rent(as % of GDP) of Other Minerals in 2006 to that in 2008?
Your answer should be very brief. 0.89. What is the ratio of the Mineral Rent(as % of GDP) in Coal in 2006 to that in 2009?
Offer a very short reply. 0.97. What is the ratio of the Mineral Rent(as % of GDP) of Natural Gas in 2006 to that in 2009?
Keep it short and to the point. 2.65. What is the ratio of the Mineral Rent(as % of GDP) in Oil in 2006 to that in 2009?
Give a very brief answer. 2.28. What is the ratio of the Mineral Rent(as % of GDP) in Other Minerals in 2006 to that in 2009?
Your response must be concise. 1.64. What is the ratio of the Mineral Rent(as % of GDP) in Coal in 2007 to that in 2008?
Provide a succinct answer. 0.35. What is the ratio of the Mineral Rent(as % of GDP) of Natural Gas in 2007 to that in 2008?
Offer a terse response. 1.03. What is the ratio of the Mineral Rent(as % of GDP) in Oil in 2007 to that in 2008?
Your response must be concise. 0.97. What is the ratio of the Mineral Rent(as % of GDP) in Other Minerals in 2007 to that in 2008?
Your response must be concise. 1.22. What is the ratio of the Mineral Rent(as % of GDP) of Coal in 2007 to that in 2009?
Provide a short and direct response. 2.52. What is the ratio of the Mineral Rent(as % of GDP) in Natural Gas in 2007 to that in 2009?
Keep it short and to the point. 2.42. What is the ratio of the Mineral Rent(as % of GDP) in Oil in 2007 to that in 2009?
Provide a short and direct response. 1.72. What is the ratio of the Mineral Rent(as % of GDP) in Other Minerals in 2007 to that in 2009?
Your answer should be compact. 2.24. What is the ratio of the Mineral Rent(as % of GDP) of Coal in 2008 to that in 2009?
Give a very brief answer. 7.22. What is the ratio of the Mineral Rent(as % of GDP) of Natural Gas in 2008 to that in 2009?
Ensure brevity in your answer.  2.35. What is the ratio of the Mineral Rent(as % of GDP) in Oil in 2008 to that in 2009?
Provide a succinct answer. 1.76. What is the ratio of the Mineral Rent(as % of GDP) of Other Minerals in 2008 to that in 2009?
Keep it short and to the point. 1.83. What is the difference between the highest and the second highest Mineral Rent(as % of GDP) in Coal?
Provide a short and direct response. 0.05. What is the difference between the highest and the second highest Mineral Rent(as % of GDP) of Natural Gas?
Your answer should be compact. 0.51. What is the difference between the highest and the second highest Mineral Rent(as % of GDP) of Oil?
Offer a very short reply. 0.95. What is the difference between the highest and the second highest Mineral Rent(as % of GDP) of Other Minerals?
Provide a short and direct response. 0.23. What is the difference between the highest and the lowest Mineral Rent(as % of GDP) in Coal?
Ensure brevity in your answer.  0.13. What is the difference between the highest and the lowest Mineral Rent(as % of GDP) in Natural Gas?
Provide a short and direct response. 2.95. What is the difference between the highest and the lowest Mineral Rent(as % of GDP) of Oil?
Provide a short and direct response. 22.08. What is the difference between the highest and the lowest Mineral Rent(as % of GDP) in Other Minerals?
Give a very brief answer. 1.02. 